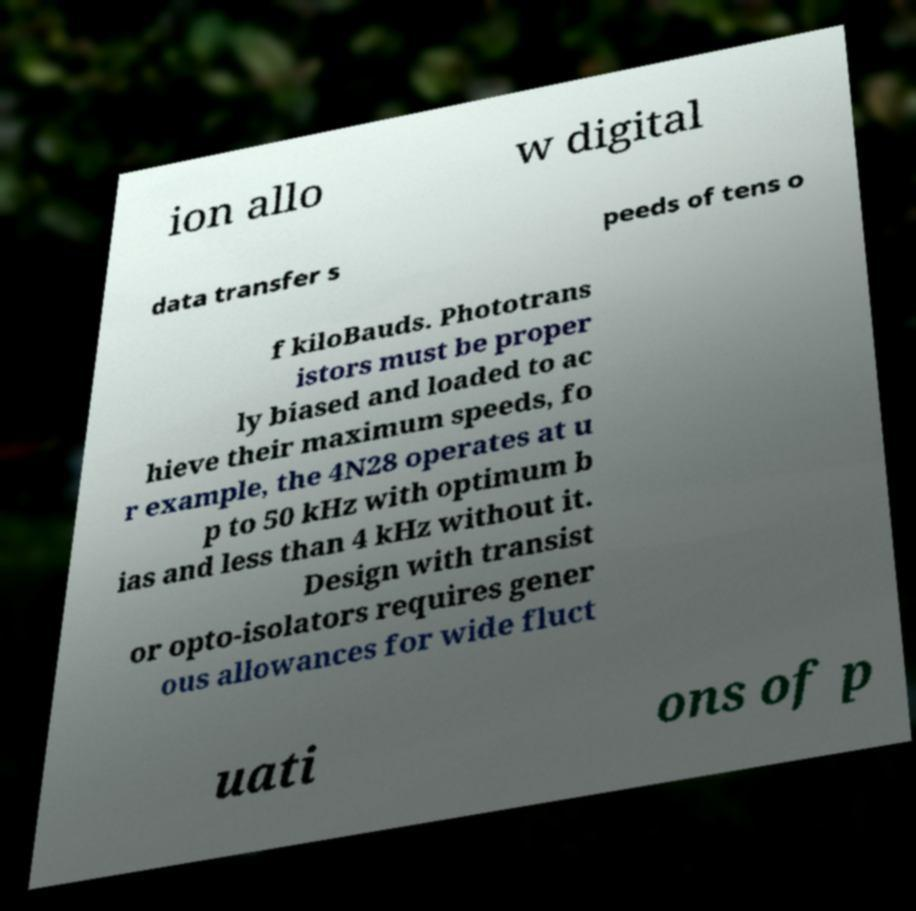Please identify and transcribe the text found in this image. ion allo w digital data transfer s peeds of tens o f kiloBauds. Phototrans istors must be proper ly biased and loaded to ac hieve their maximum speeds, fo r example, the 4N28 operates at u p to 50 kHz with optimum b ias and less than 4 kHz without it. Design with transist or opto-isolators requires gener ous allowances for wide fluct uati ons of p 